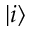<formula> <loc_0><loc_0><loc_500><loc_500>| i \rangle</formula> 